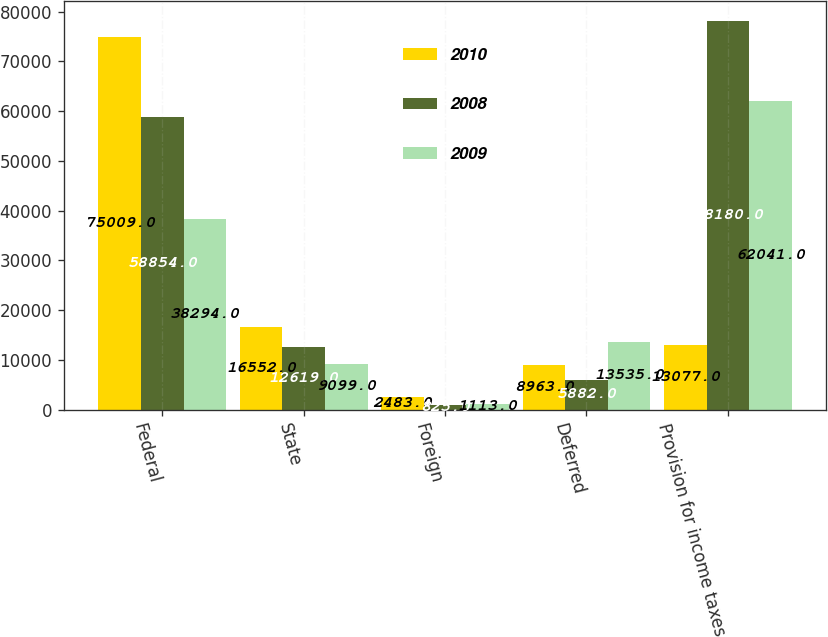<chart> <loc_0><loc_0><loc_500><loc_500><stacked_bar_chart><ecel><fcel>Federal<fcel>State<fcel>Foreign<fcel>Deferred<fcel>Provision for income taxes<nl><fcel>2010<fcel>75009<fcel>16552<fcel>2483<fcel>8963<fcel>13077<nl><fcel>2008<fcel>58854<fcel>12619<fcel>825<fcel>5882<fcel>78180<nl><fcel>2009<fcel>38294<fcel>9099<fcel>1113<fcel>13535<fcel>62041<nl></chart> 